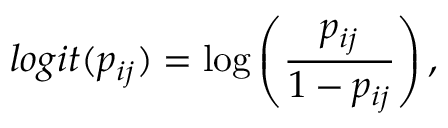Convert formula to latex. <formula><loc_0><loc_0><loc_500><loc_500>\log i t ( p _ { i j } ) = \log \left ( \frac { p _ { i j } } { 1 - p _ { i j } } \right ) ,</formula> 